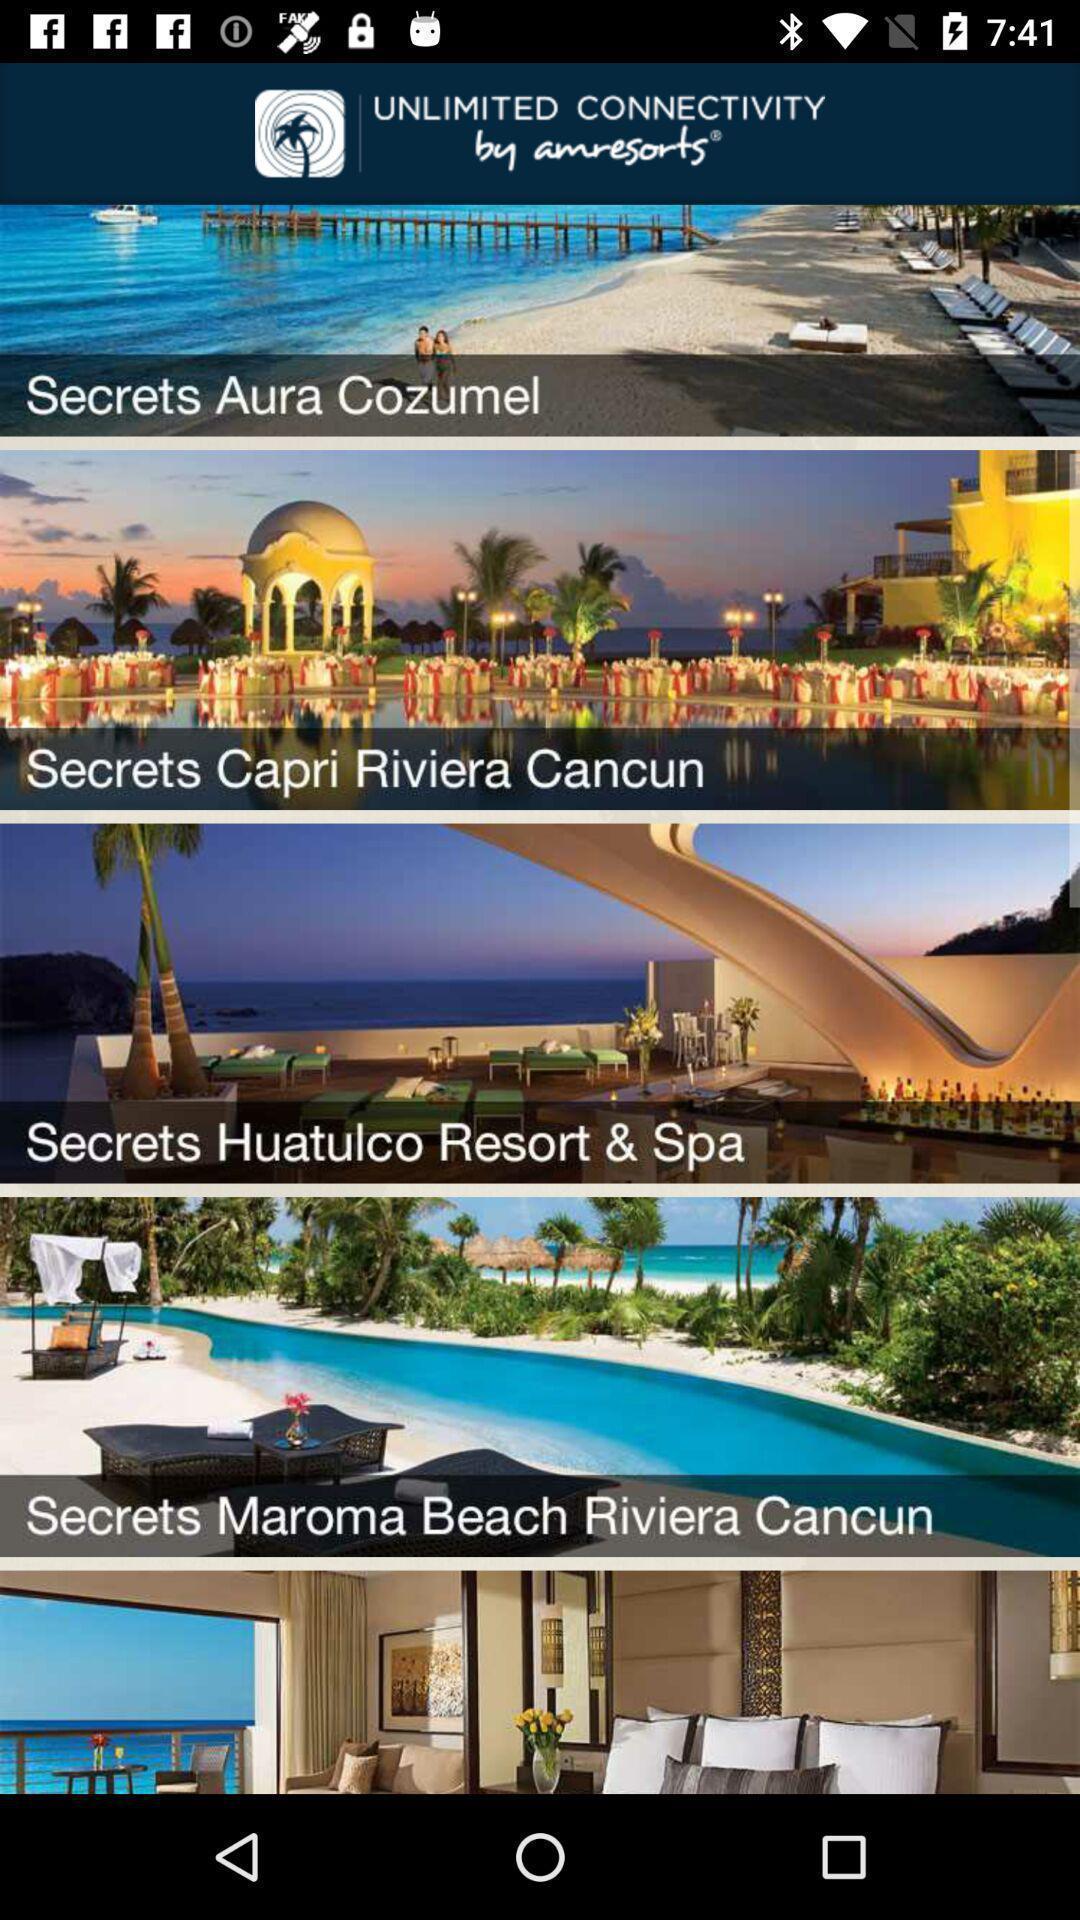What details can you identify in this image? Screen shows different vacation spots. 